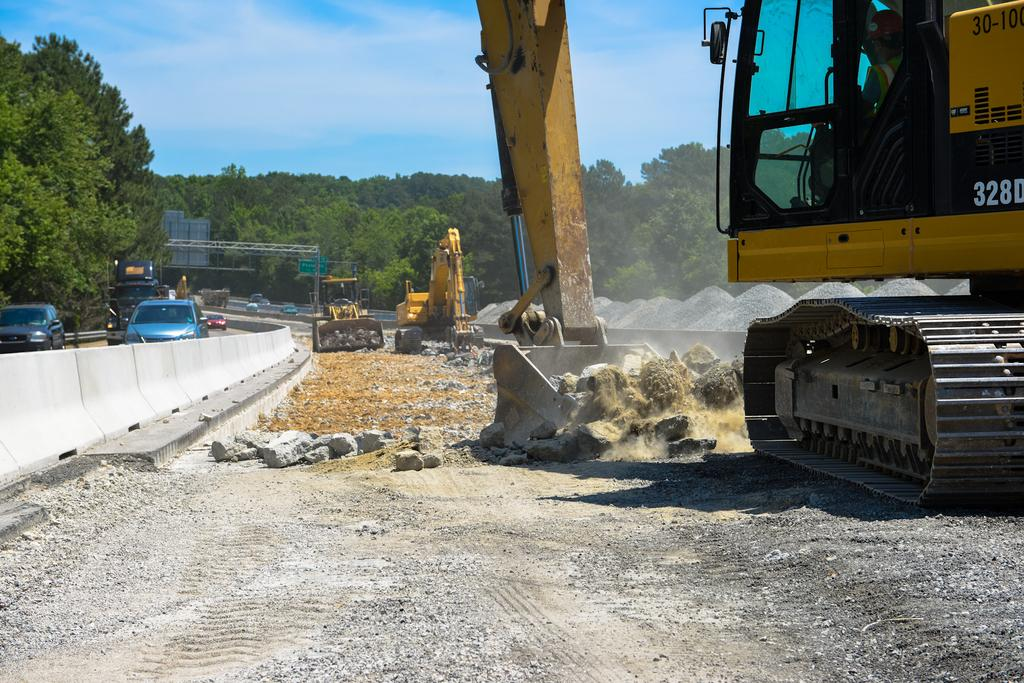What type of machinery can be seen in the image? There are excavators in the image. What else can be seen on the road in the image? There are vehicles on the road in the image. What is located behind the excavators and vehicles? There are trees behind the excavators and vehicles. What structures are present in the image? There are poles and sign boards in the image. What is visible at the top of the image? Clouds and the sky are visible at the top of the image. Can you see a bridge connecting the two mountains in the image? There is no bridge or mountains present in the image. Are there any police officers directing traffic in the image? There is no mention of police officers or traffic in the image. 